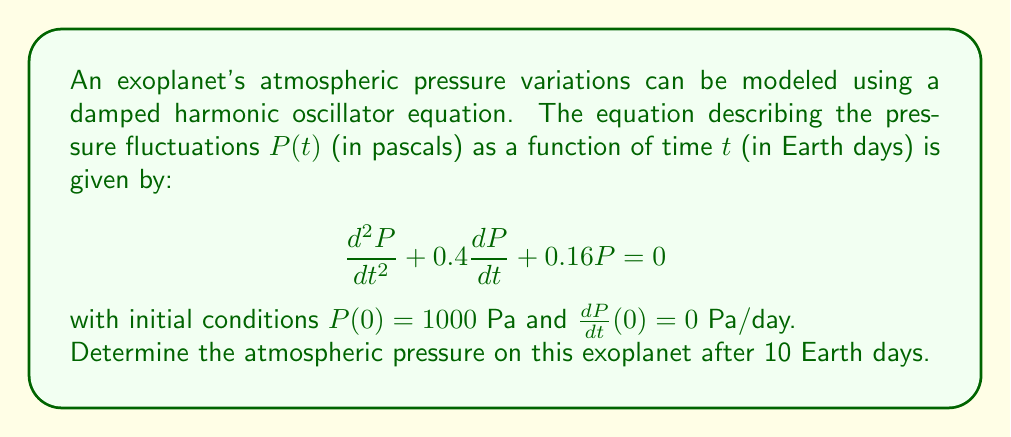What is the answer to this math problem? To solve this problem, we need to follow these steps:

1) The general solution for a damped harmonic oscillator is of the form:
   $$P(t) = e^{-\beta t}(A\cos(\omega t) + B\sin(\omega t))$$

2) From the given equation, we can identify:
   $\beta = 0.2$ and $\omega^2 = 0.16 - \beta^2 = 0.12$
   So, $\omega = \sqrt{0.12} \approx 0.3464$

3) The general solution becomes:
   $$P(t) = e^{-0.2t}(A\cos(0.3464t) + B\sin(0.3464t))$$

4) Using the initial conditions:
   $P(0) = 1000 = A$
   $\frac{dP}{dt}(0) = 0 = -0.2A + 0.3464B$

5) Solving for B:
   $B = \frac{0.2A}{0.3464} \approx 577.3669$

6) Our specific solution is:
   $$P(t) = e^{-0.2t}(1000\cos(0.3464t) + 577.3669\sin(0.3464t))$$

7) To find the pressure after 10 days, we substitute $t = 10$:
   $$P(10) = e^{-0.2(10)}(1000\cos(0.3464(10)) + 577.3669\sin(0.3464(10)))$$

8) Calculating this:
   $$P(10) = 0.1353 * (1000 * (-0.9414) + 577.3669 * 0.3373) \approx 152.6724$$
Answer: The atmospheric pressure on the exoplanet after 10 Earth days is approximately 152.67 Pa. 